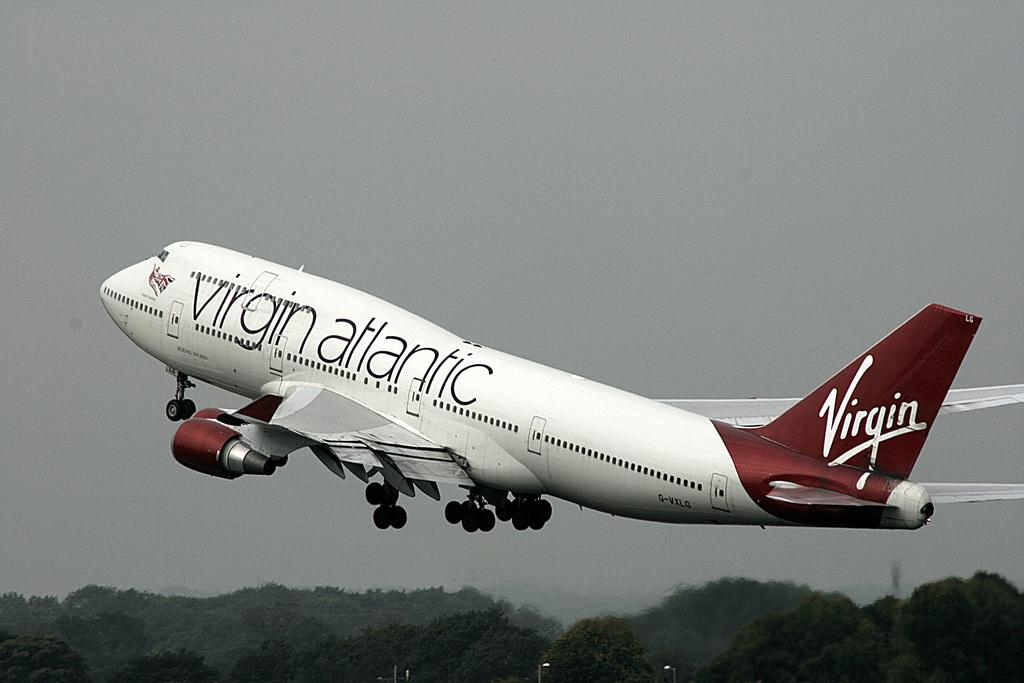What is the main subject in the image? There is a plane in the air in the image. What type of natural vegetation can be seen in the image? There are trees visible in the image. What type of faucet can be seen in the image? There is no faucet present in the image. What material is the plane made of in the image? The image does not provide information about the material of the plane. 